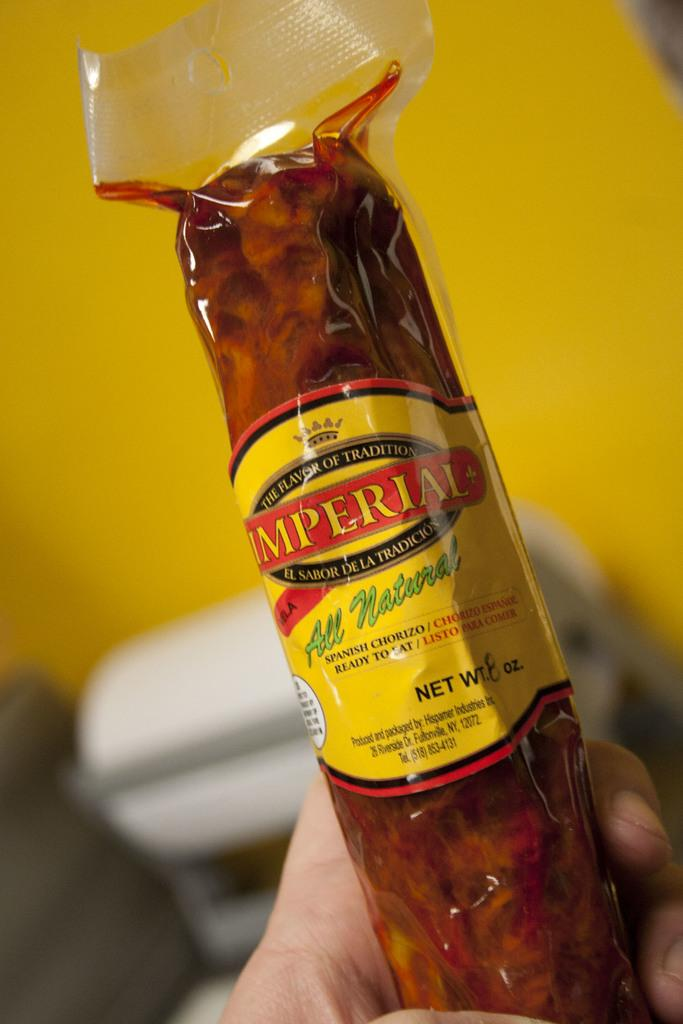<image>
Give a short and clear explanation of the subsequent image. A stick of Imperial brand chorizo sausage being held in a hand. 